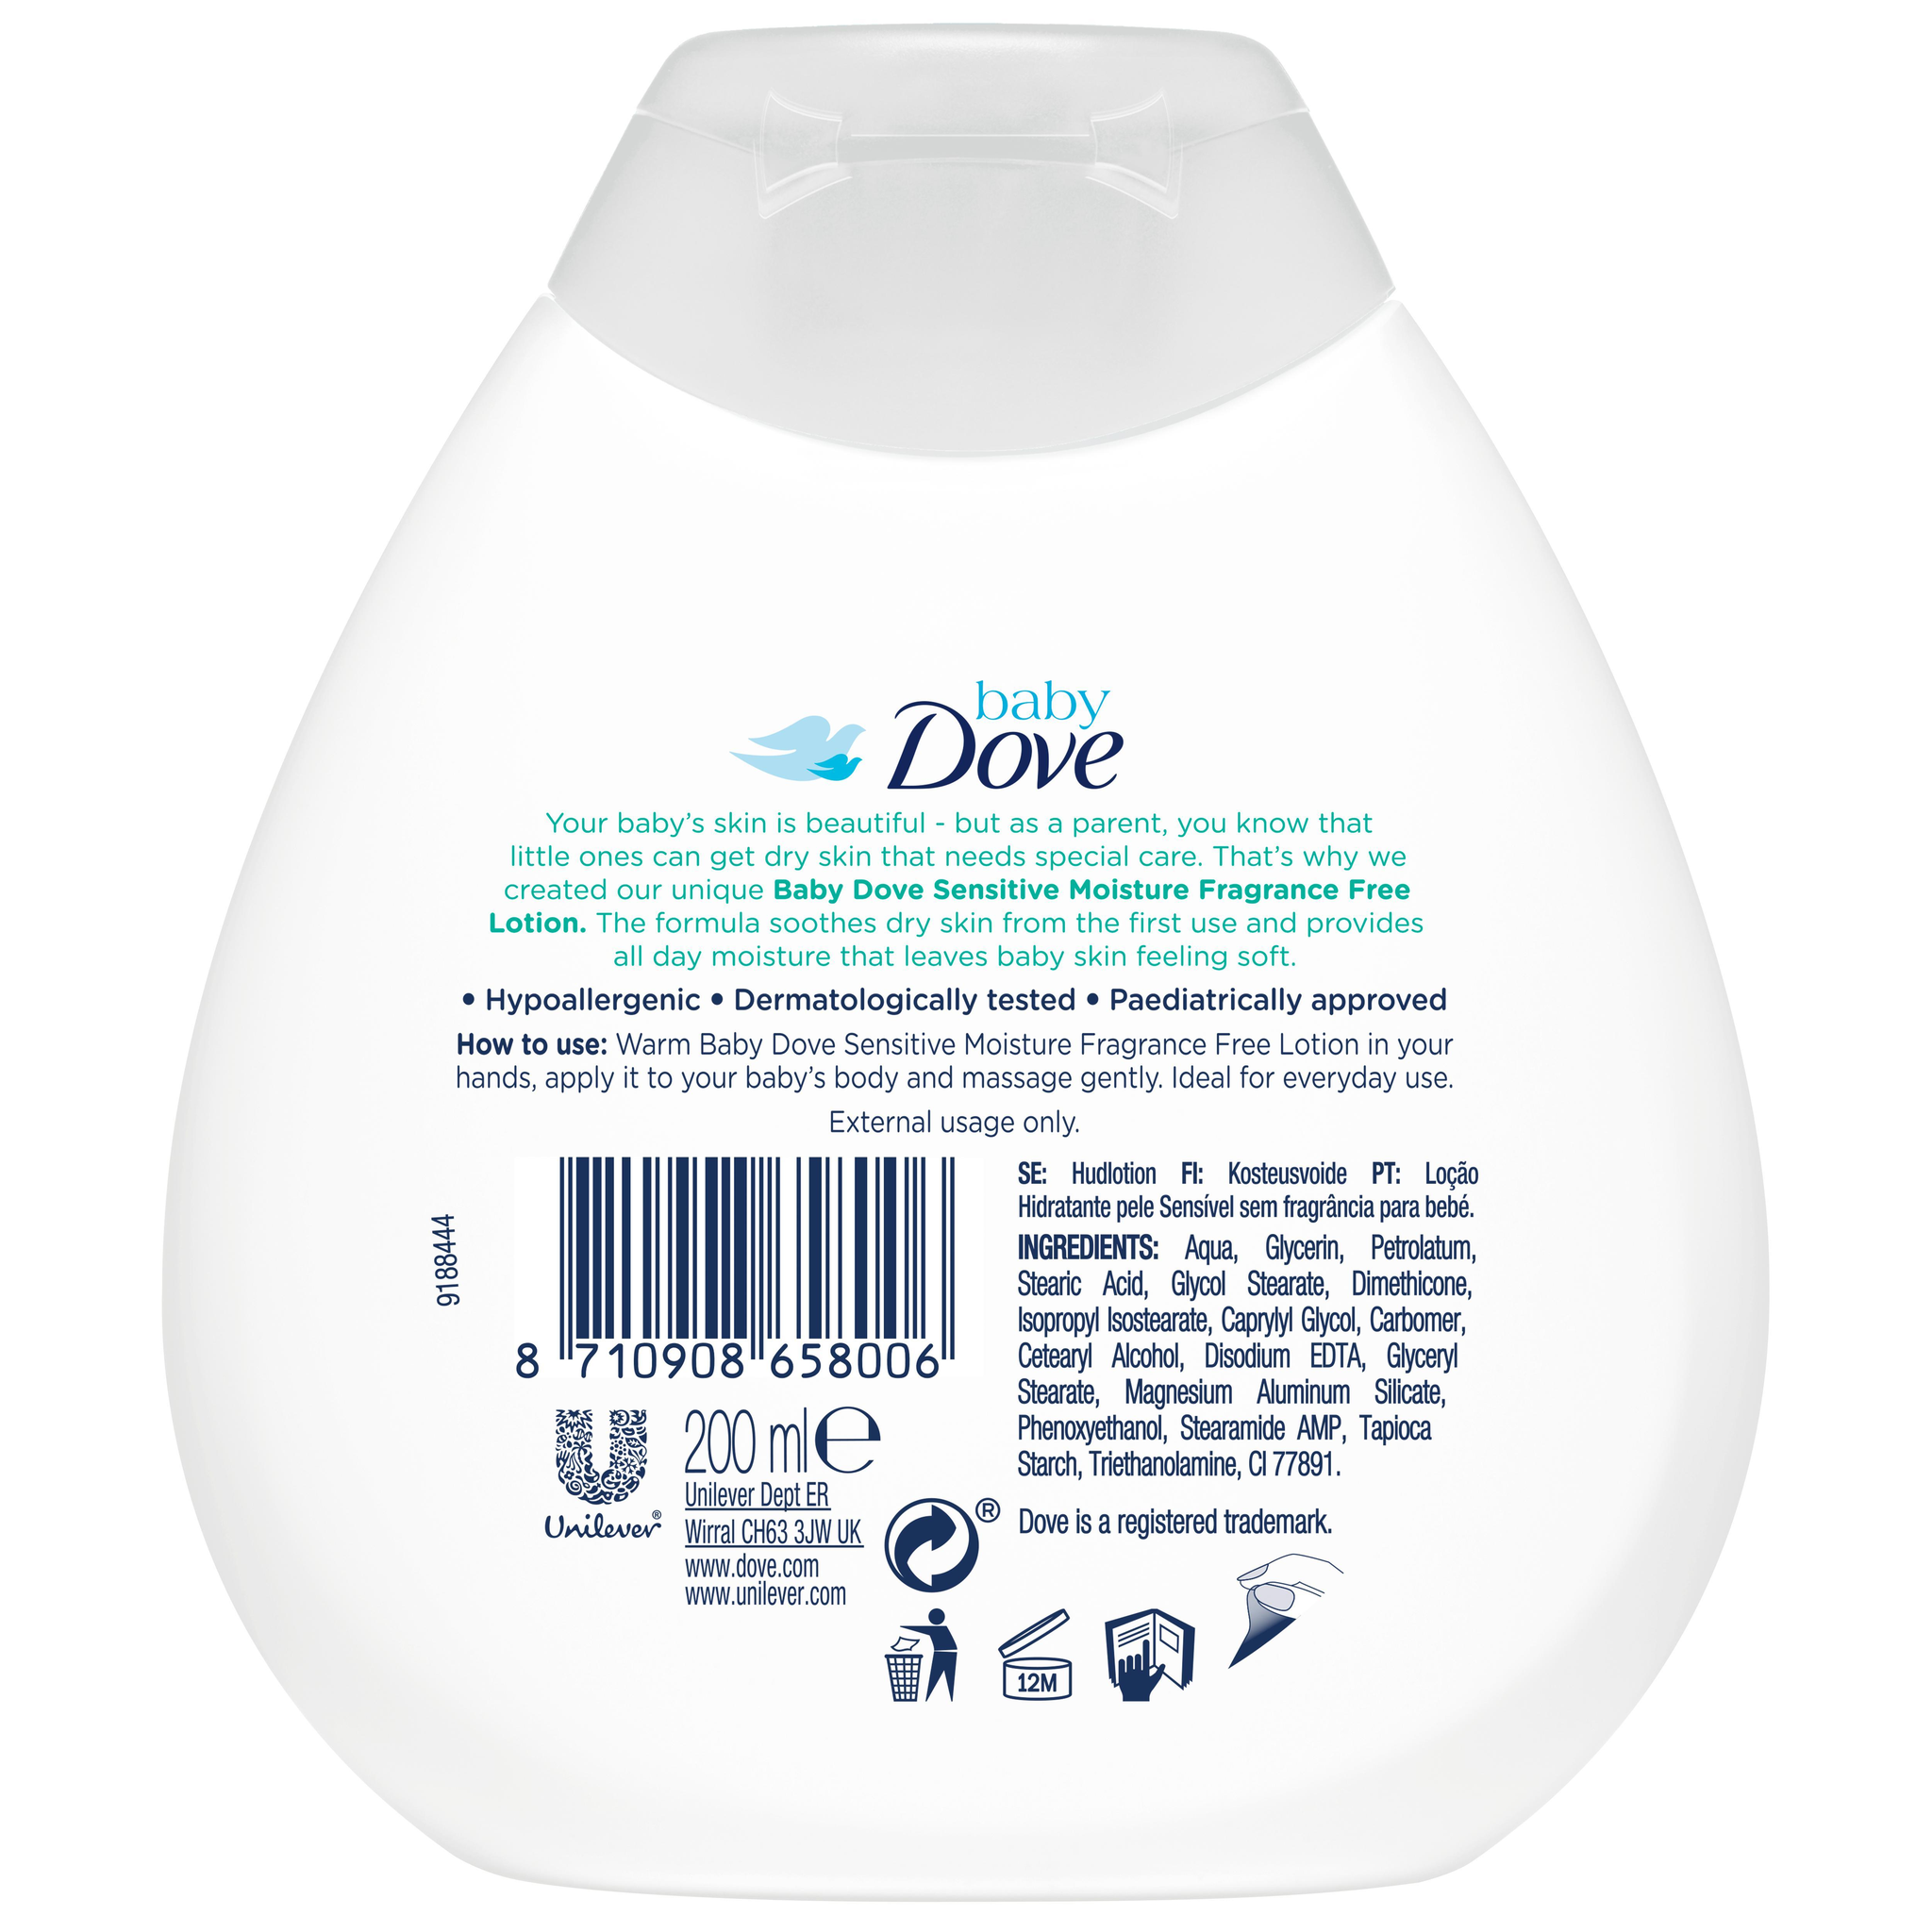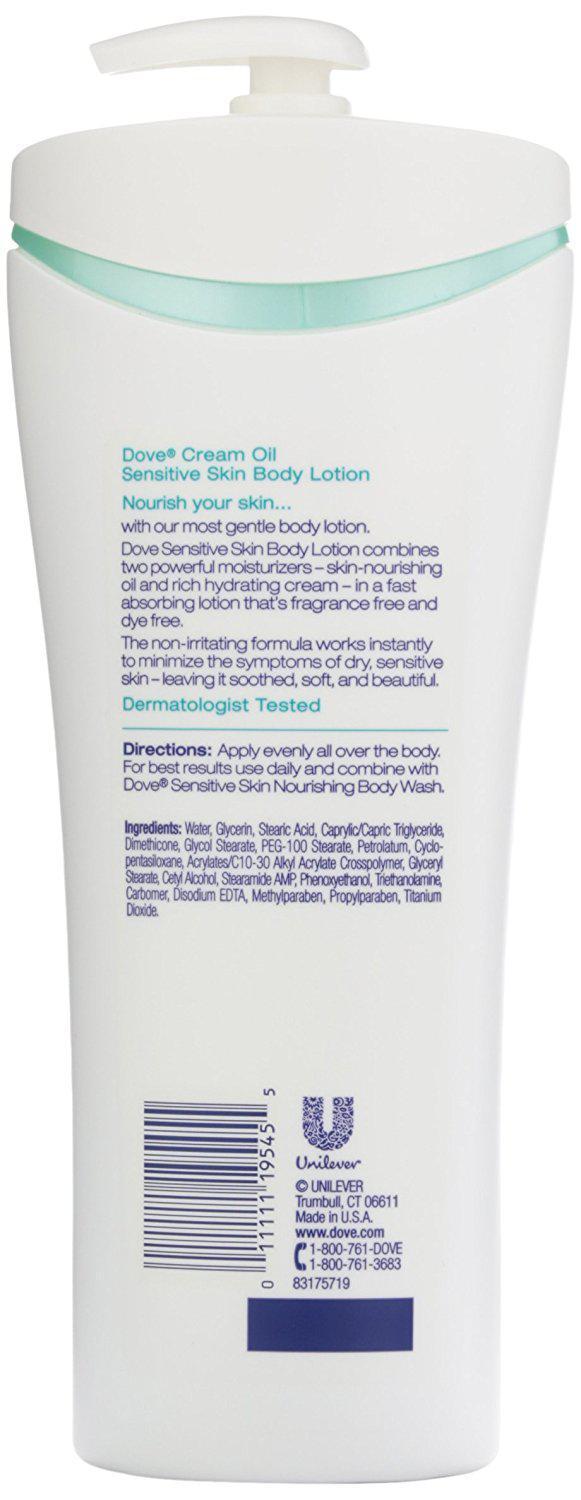The first image is the image on the left, the second image is the image on the right. Considering the images on both sides, is "The right image contains one pump-top product with its nozzle facing left, and the left image contains a product without a pump top." valid? Answer yes or no. Yes. The first image is the image on the left, the second image is the image on the right. For the images shown, is this caption "In the image on the right, the bottle of soap has a top pump dispenser." true? Answer yes or no. Yes. 